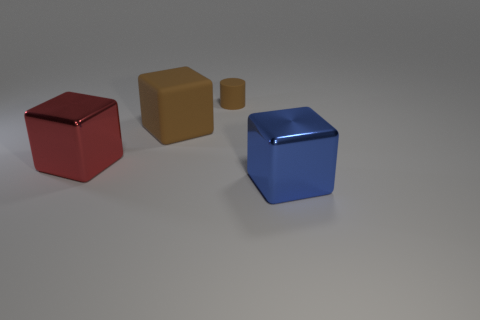Are there any other things that have the same size as the cylinder?
Your answer should be very brief. No. How many things are either large brown rubber cubes or big cubes that are in front of the large brown thing?
Your answer should be compact. 3. There is a red block that is the same size as the blue metal object; what material is it?
Offer a terse response. Metal. Are the big brown object and the tiny object made of the same material?
Your answer should be very brief. Yes. What color is the big object that is both in front of the big rubber block and left of the small brown matte cylinder?
Offer a very short reply. Red. Does the big thing that is to the left of the big rubber block have the same color as the large matte cube?
Ensure brevity in your answer.  No. What is the shape of the blue object that is the same size as the rubber cube?
Your answer should be compact. Cube. How many other things are made of the same material as the big brown thing?
Your answer should be very brief. 1. There is a red block; is its size the same as the rubber thing that is right of the brown cube?
Offer a terse response. No. What color is the rubber cylinder?
Ensure brevity in your answer.  Brown. 